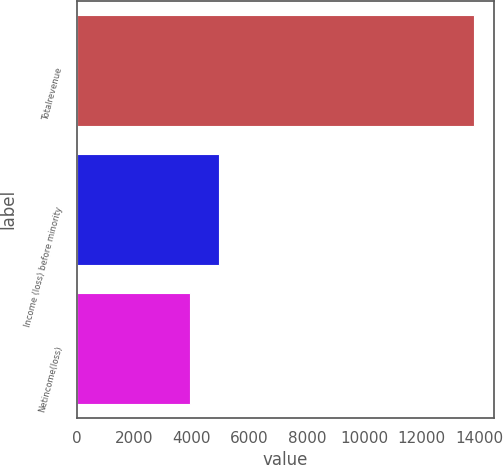Convert chart to OTSL. <chart><loc_0><loc_0><loc_500><loc_500><bar_chart><fcel>Totalrevenue<fcel>Income (loss) before minority<fcel>Netincome(loss)<nl><fcel>13824<fcel>4925.7<fcel>3937<nl></chart> 